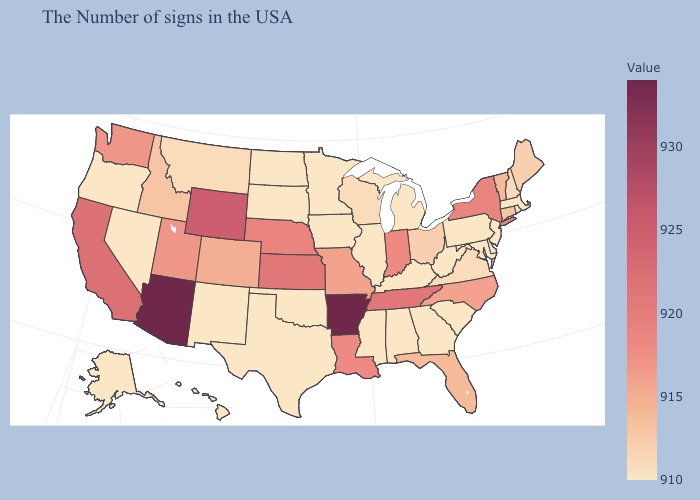Does the map have missing data?
Concise answer only. No. Which states hav the highest value in the South?
Short answer required. Arkansas. Which states have the lowest value in the West?
Be succinct. New Mexico, Nevada, Oregon, Alaska, Hawaii. Among the states that border Minnesota , which have the highest value?
Short answer required. Wisconsin. Does Rhode Island have a lower value than Missouri?
Give a very brief answer. Yes. 